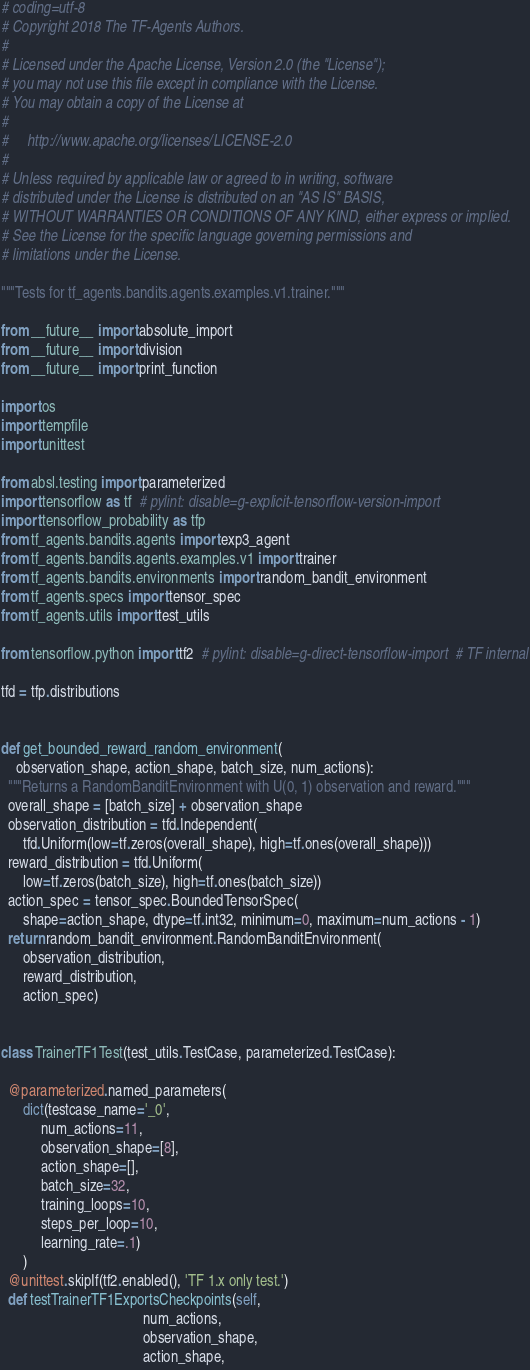<code> <loc_0><loc_0><loc_500><loc_500><_Python_># coding=utf-8
# Copyright 2018 The TF-Agents Authors.
#
# Licensed under the Apache License, Version 2.0 (the "License");
# you may not use this file except in compliance with the License.
# You may obtain a copy of the License at
#
#     http://www.apache.org/licenses/LICENSE-2.0
#
# Unless required by applicable law or agreed to in writing, software
# distributed under the License is distributed on an "AS IS" BASIS,
# WITHOUT WARRANTIES OR CONDITIONS OF ANY KIND, either express or implied.
# See the License for the specific language governing permissions and
# limitations under the License.

"""Tests for tf_agents.bandits.agents.examples.v1.trainer."""

from __future__ import absolute_import
from __future__ import division
from __future__ import print_function

import os
import tempfile
import unittest

from absl.testing import parameterized
import tensorflow as tf  # pylint: disable=g-explicit-tensorflow-version-import
import tensorflow_probability as tfp
from tf_agents.bandits.agents import exp3_agent
from tf_agents.bandits.agents.examples.v1 import trainer
from tf_agents.bandits.environments import random_bandit_environment
from tf_agents.specs import tensor_spec
from tf_agents.utils import test_utils

from tensorflow.python import tf2  # pylint: disable=g-direct-tensorflow-import  # TF internal

tfd = tfp.distributions


def get_bounded_reward_random_environment(
    observation_shape, action_shape, batch_size, num_actions):
  """Returns a RandomBanditEnvironment with U(0, 1) observation and reward."""
  overall_shape = [batch_size] + observation_shape
  observation_distribution = tfd.Independent(
      tfd.Uniform(low=tf.zeros(overall_shape), high=tf.ones(overall_shape)))
  reward_distribution = tfd.Uniform(
      low=tf.zeros(batch_size), high=tf.ones(batch_size))
  action_spec = tensor_spec.BoundedTensorSpec(
      shape=action_shape, dtype=tf.int32, minimum=0, maximum=num_actions - 1)
  return random_bandit_environment.RandomBanditEnvironment(
      observation_distribution,
      reward_distribution,
      action_spec)


class TrainerTF1Test(test_utils.TestCase, parameterized.TestCase):

  @parameterized.named_parameters(
      dict(testcase_name='_0',
           num_actions=11,
           observation_shape=[8],
           action_shape=[],
           batch_size=32,
           training_loops=10,
           steps_per_loop=10,
           learning_rate=.1)
      )
  @unittest.skipIf(tf2.enabled(), 'TF 1.x only test.')
  def testTrainerTF1ExportsCheckpoints(self,
                                       num_actions,
                                       observation_shape,
                                       action_shape,</code> 